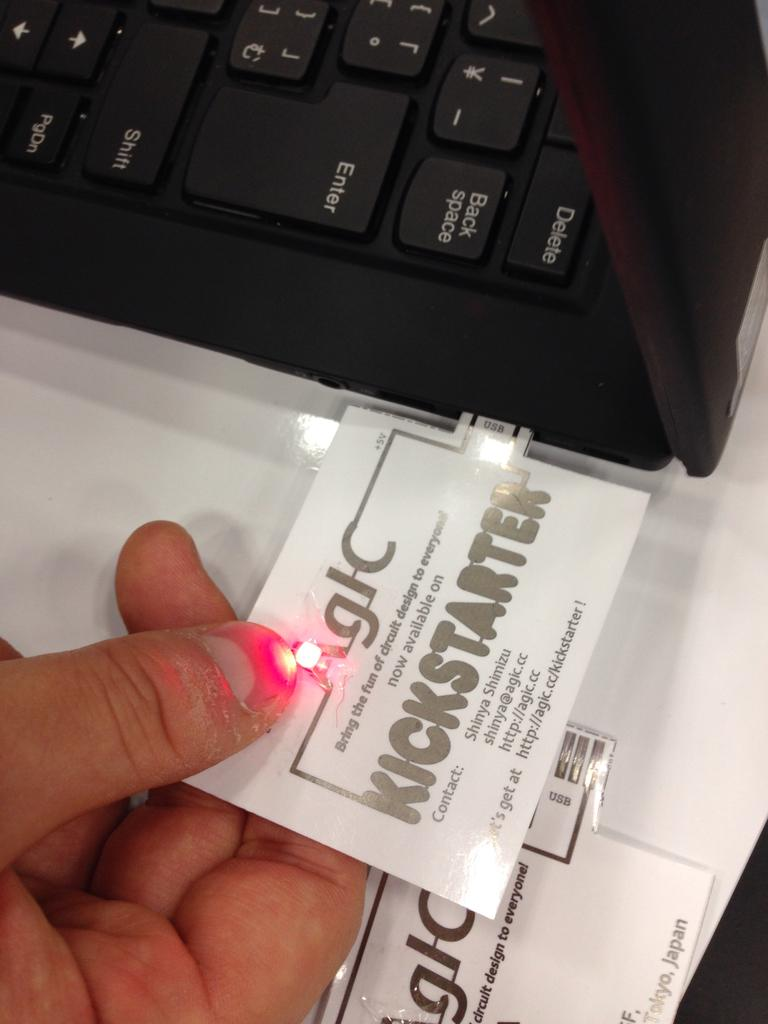What is the person in the image doing? The person is holding a chip in the image. What else can be seen in the image besides the person? There is a laptop visible in the image. Are there any other chips in the image? Yes, there is another chip at the bottom of the image. Is the person in the image trying to be quiet while holding the chip? The image does not provide any information about the person's intention to be quiet or not. 